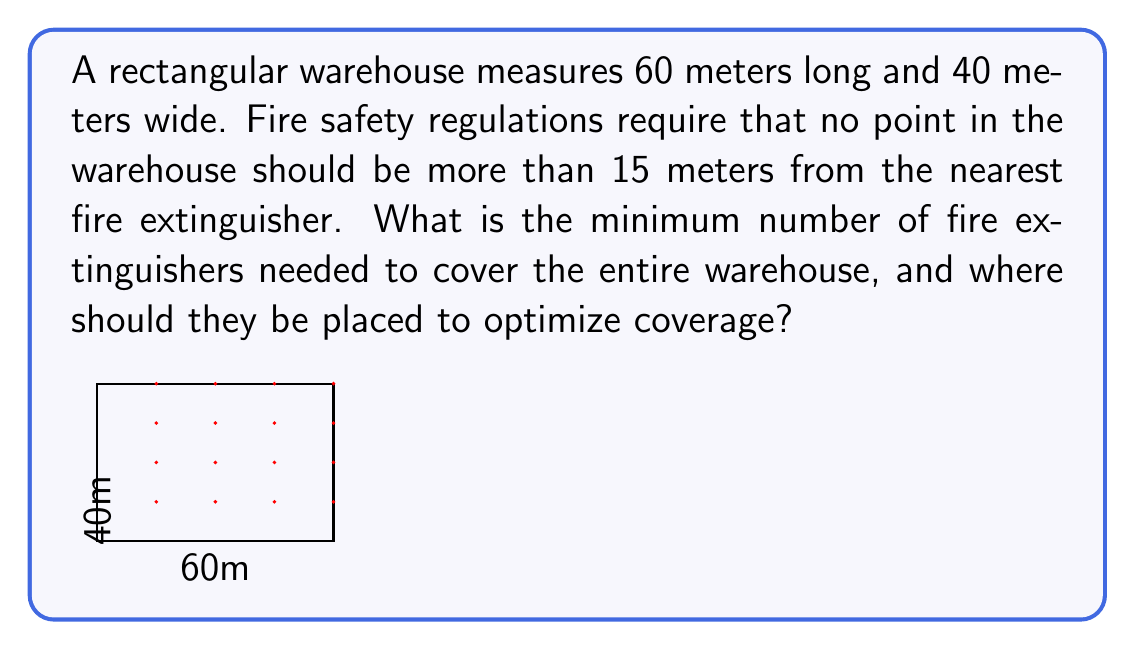Show me your answer to this math problem. To solve this problem, we'll use the concept of geometric optimization:

1) First, we need to understand that the optimal placement of fire extinguishers will form a grid pattern to maximize coverage with minimal overlap.

2) The radius of coverage for each extinguisher is 15 meters. This means each extinguisher can cover a circular area with a diameter of 30 meters.

3) To cover the entire warehouse, we need to determine how many 30-meter segments fit into the length and width of the warehouse:

   Length: $\frac{60\text{ m}}{30\text{ m}} = 2$ segments
   Width: $\frac{40\text{ m}}{30\text{ m}} \approx 1.33$ segments

4) Rounding up (as we need full coverage), we need 3 segments along the length and 2 segments along the width.

5) The number of fire extinguishers needed is the product of these numbers:

   $3 \times 2 = 6$ fire extinguishers

6) To optimize placement, we divide the warehouse into a 3x2 grid:

   Length spacing: $\frac{60\text{ m}}{3} = 20\text{ m}$
   Width spacing: $\frac{40\text{ m}}{2} = 20\text{ m}$

7) The fire extinguishers should be placed at the center of each grid cell. The coordinates (in meters) from the bottom-left corner of the warehouse are:

   $$(15, 10), (35, 10), (55, 10)$$
   $$(15, 30), (35, 30), (55, 30)$$

This placement ensures that no point in the warehouse is more than 15 meters from the nearest fire extinguisher, satisfying the safety regulation while using the minimum number of extinguishers.
Answer: The minimum number of fire extinguishers needed is 6. They should be placed in a 3x2 grid pattern with coordinates (in meters from the bottom-left corner): $(15, 10)$, $(35, 10)$, $(55, 10)$, $(15, 30)$, $(35, 30)$, and $(55, 30)$. 